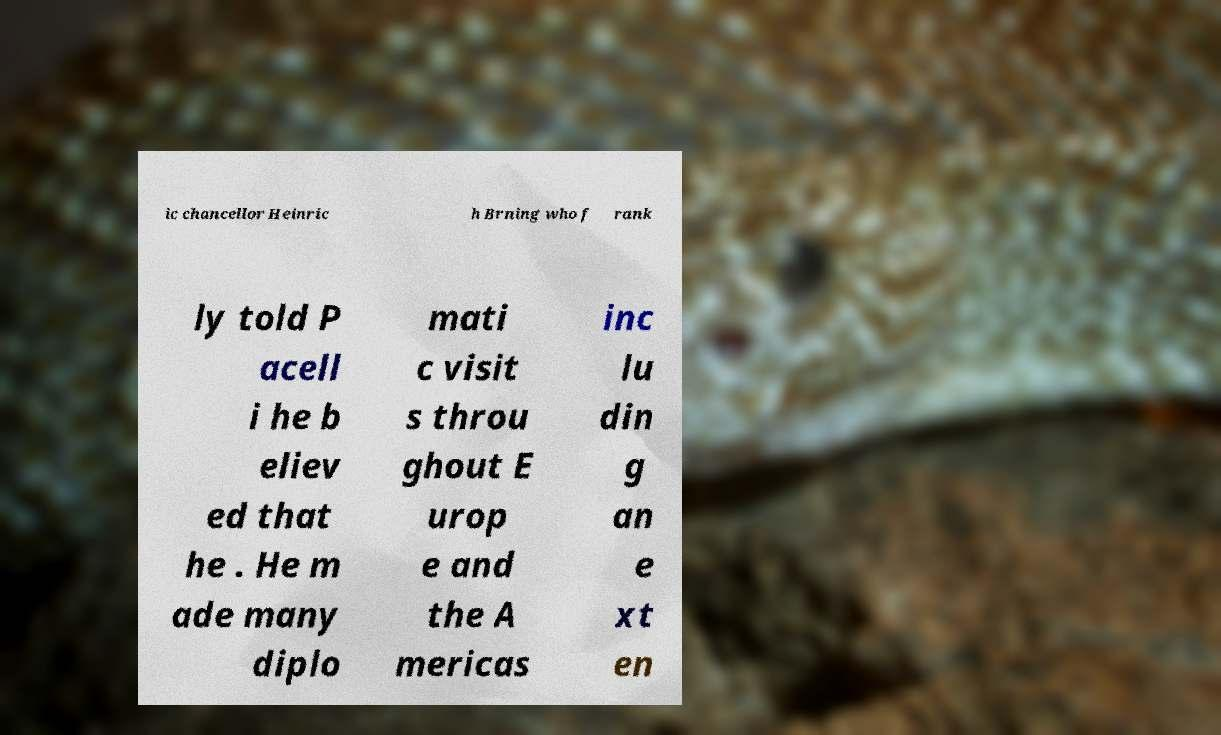Can you read and provide the text displayed in the image?This photo seems to have some interesting text. Can you extract and type it out for me? ic chancellor Heinric h Brning who f rank ly told P acell i he b eliev ed that he . He m ade many diplo mati c visit s throu ghout E urop e and the A mericas inc lu din g an e xt en 